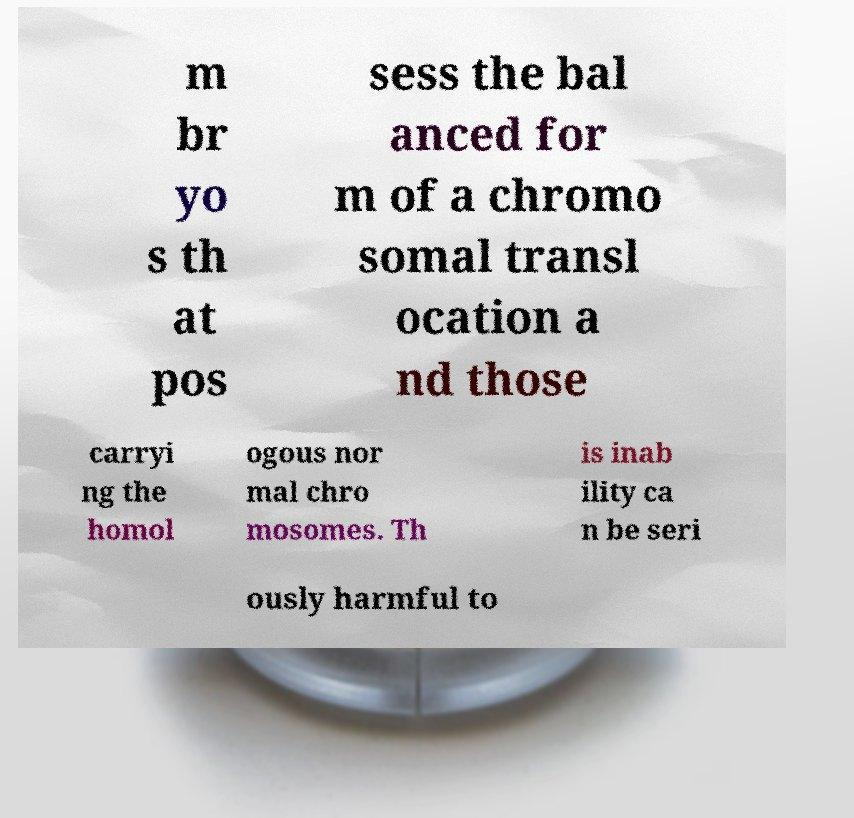Can you read and provide the text displayed in the image?This photo seems to have some interesting text. Can you extract and type it out for me? m br yo s th at pos sess the bal anced for m of a chromo somal transl ocation a nd those carryi ng the homol ogous nor mal chro mosomes. Th is inab ility ca n be seri ously harmful to 